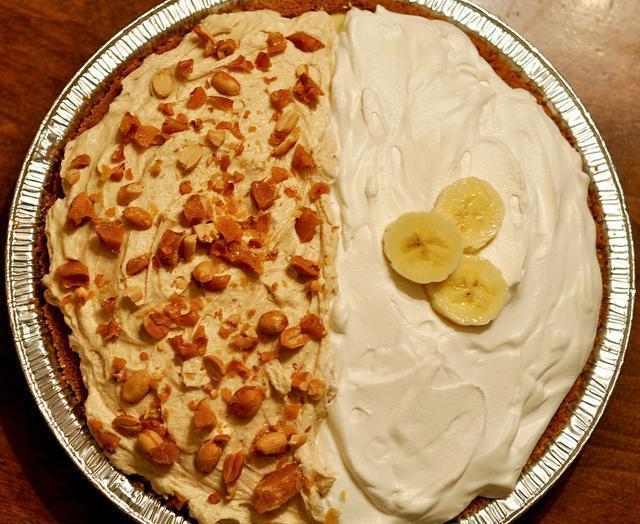Is the statement "The banana is at the right side of the cake." accurate regarding the image?
Answer yes or no. Yes. 